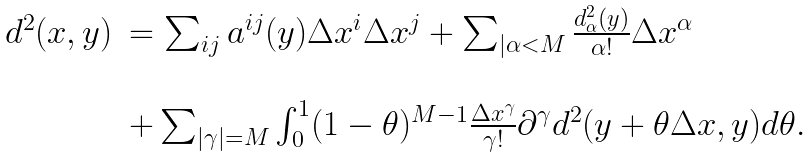Convert formula to latex. <formula><loc_0><loc_0><loc_500><loc_500>\begin{array} { l l } d ^ { 2 } ( x , y ) & = \sum _ { i j } a ^ { i j } ( y ) \Delta x ^ { i } \Delta x ^ { j } + \sum _ { | \alpha < M } \frac { d ^ { 2 } _ { \alpha } ( y ) } { \alpha ! } \Delta x ^ { \alpha } \\ \\ & + \sum _ { | \gamma | = M } \int _ { 0 } ^ { 1 } ( 1 - \theta ) ^ { M - 1 } \frac { \Delta x ^ { \gamma } } { \gamma ! } \partial ^ { \gamma } d ^ { 2 } ( y + \theta \Delta x , y ) d \theta . \end{array}</formula> 